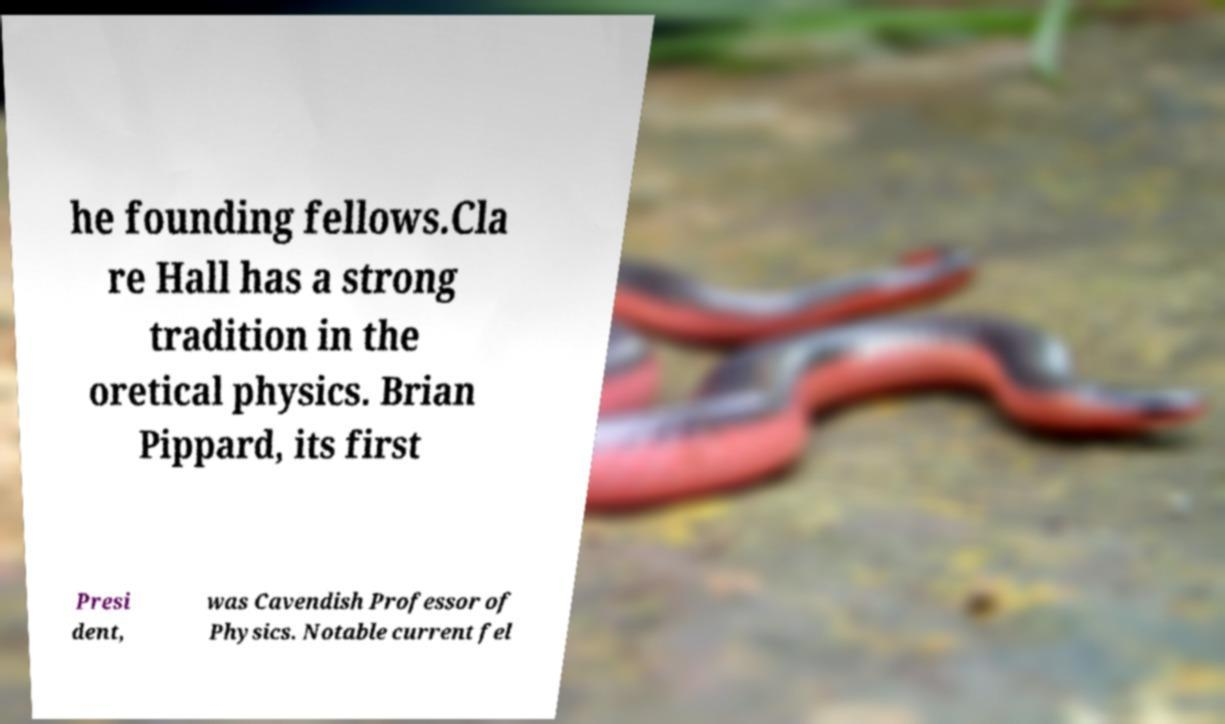I need the written content from this picture converted into text. Can you do that? he founding fellows.Cla re Hall has a strong tradition in the oretical physics. Brian Pippard, its first Presi dent, was Cavendish Professor of Physics. Notable current fel 